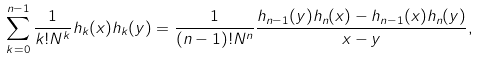<formula> <loc_0><loc_0><loc_500><loc_500>\sum _ { k = 0 } ^ { n - 1 } \frac { 1 } { k ! N ^ { k } } h _ { k } ( x ) h _ { k } ( y ) = \frac { 1 } { ( n - 1 ) ! N ^ { n } } \frac { h _ { n - 1 } ( y ) h _ { n } ( x ) - h _ { n - 1 } ( x ) h _ { n } ( y ) } { x - y } ,</formula> 